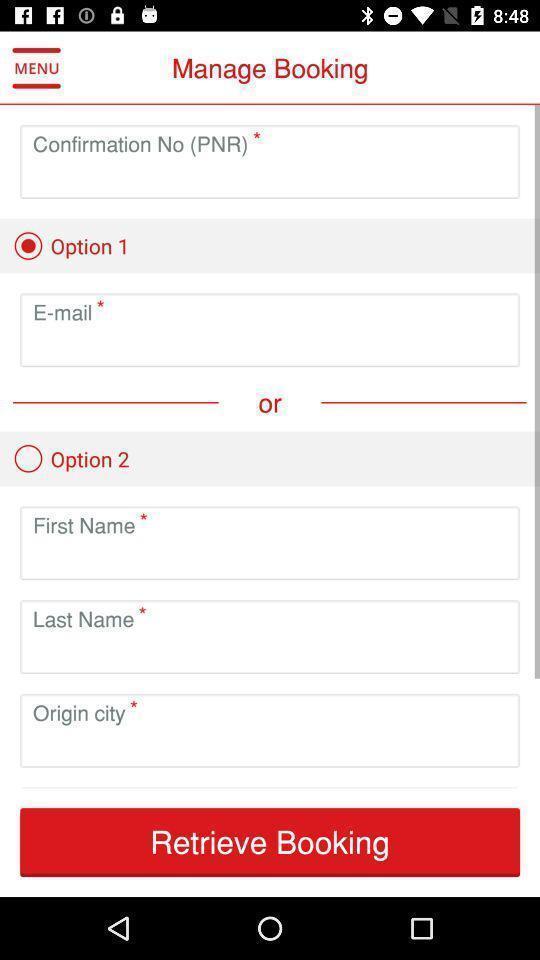What is the overall content of this screenshot? Screen shows booking options in an travel application. 